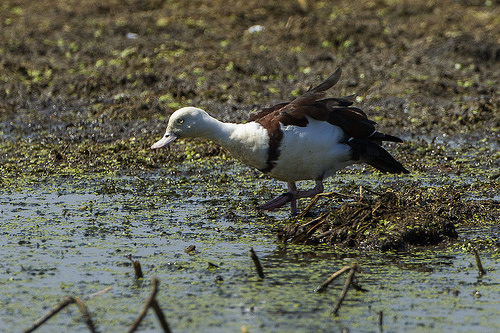<image>
Is the bill on the duck? Yes. Looking at the image, I can see the bill is positioned on top of the duck, with the duck providing support. 